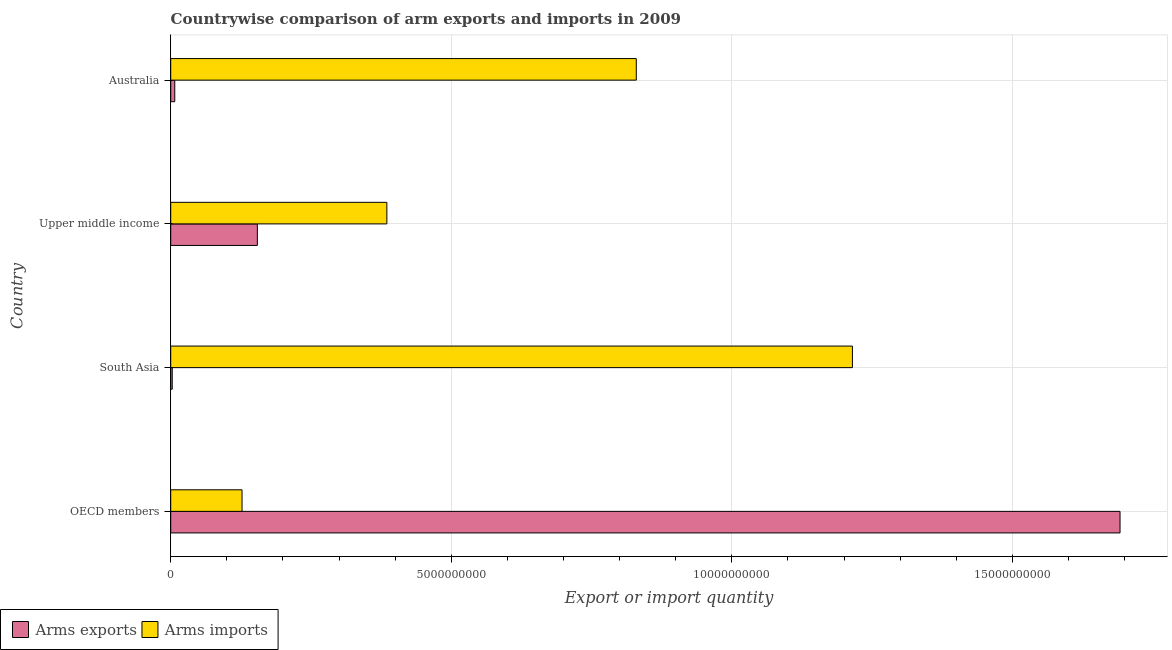How many different coloured bars are there?
Keep it short and to the point. 2. How many groups of bars are there?
Your answer should be very brief. 4. Are the number of bars per tick equal to the number of legend labels?
Offer a terse response. Yes. How many bars are there on the 1st tick from the top?
Give a very brief answer. 2. What is the arms exports in OECD members?
Ensure brevity in your answer.  1.69e+1. Across all countries, what is the maximum arms exports?
Your answer should be compact. 1.69e+1. Across all countries, what is the minimum arms imports?
Provide a succinct answer. 1.27e+09. In which country was the arms imports maximum?
Keep it short and to the point. South Asia. In which country was the arms exports minimum?
Your answer should be very brief. South Asia. What is the total arms imports in the graph?
Provide a short and direct response. 2.56e+1. What is the difference between the arms imports in Australia and that in Upper middle income?
Your answer should be very brief. 4.44e+09. What is the difference between the arms imports in Australia and the arms exports in OECD members?
Keep it short and to the point. -8.62e+09. What is the average arms imports per country?
Offer a very short reply. 6.39e+09. What is the difference between the arms imports and arms exports in Upper middle income?
Give a very brief answer. 2.31e+09. What is the ratio of the arms exports in OECD members to that in South Asia?
Your response must be concise. 626.59. Is the difference between the arms exports in Australia and Upper middle income greater than the difference between the arms imports in Australia and Upper middle income?
Provide a short and direct response. No. What is the difference between the highest and the second highest arms exports?
Your answer should be compact. 1.54e+1. What is the difference between the highest and the lowest arms exports?
Offer a terse response. 1.69e+1. What does the 1st bar from the top in OECD members represents?
Ensure brevity in your answer.  Arms imports. What does the 2nd bar from the bottom in OECD members represents?
Give a very brief answer. Arms imports. How many bars are there?
Offer a terse response. 8. What is the difference between two consecutive major ticks on the X-axis?
Offer a terse response. 5.00e+09. Are the values on the major ticks of X-axis written in scientific E-notation?
Offer a very short reply. No. Where does the legend appear in the graph?
Offer a very short reply. Bottom left. How are the legend labels stacked?
Keep it short and to the point. Horizontal. What is the title of the graph?
Provide a succinct answer. Countrywise comparison of arm exports and imports in 2009. What is the label or title of the X-axis?
Provide a short and direct response. Export or import quantity. What is the label or title of the Y-axis?
Offer a terse response. Country. What is the Export or import quantity of Arms exports in OECD members?
Ensure brevity in your answer.  1.69e+1. What is the Export or import quantity in Arms imports in OECD members?
Offer a terse response. 1.27e+09. What is the Export or import quantity of Arms exports in South Asia?
Your response must be concise. 2.70e+07. What is the Export or import quantity of Arms imports in South Asia?
Offer a very short reply. 1.21e+1. What is the Export or import quantity of Arms exports in Upper middle income?
Offer a very short reply. 1.54e+09. What is the Export or import quantity of Arms imports in Upper middle income?
Your answer should be compact. 3.85e+09. What is the Export or import quantity of Arms exports in Australia?
Make the answer very short. 7.20e+07. What is the Export or import quantity of Arms imports in Australia?
Give a very brief answer. 8.30e+09. Across all countries, what is the maximum Export or import quantity of Arms exports?
Offer a terse response. 1.69e+1. Across all countries, what is the maximum Export or import quantity in Arms imports?
Your answer should be very brief. 1.21e+1. Across all countries, what is the minimum Export or import quantity of Arms exports?
Make the answer very short. 2.70e+07. Across all countries, what is the minimum Export or import quantity in Arms imports?
Your response must be concise. 1.27e+09. What is the total Export or import quantity of Arms exports in the graph?
Ensure brevity in your answer.  1.86e+1. What is the total Export or import quantity in Arms imports in the graph?
Provide a short and direct response. 2.56e+1. What is the difference between the Export or import quantity in Arms exports in OECD members and that in South Asia?
Ensure brevity in your answer.  1.69e+1. What is the difference between the Export or import quantity in Arms imports in OECD members and that in South Asia?
Your answer should be compact. -1.09e+1. What is the difference between the Export or import quantity in Arms exports in OECD members and that in Upper middle income?
Provide a short and direct response. 1.54e+1. What is the difference between the Export or import quantity in Arms imports in OECD members and that in Upper middle income?
Offer a terse response. -2.58e+09. What is the difference between the Export or import quantity of Arms exports in OECD members and that in Australia?
Give a very brief answer. 1.68e+1. What is the difference between the Export or import quantity of Arms imports in OECD members and that in Australia?
Provide a short and direct response. -7.03e+09. What is the difference between the Export or import quantity of Arms exports in South Asia and that in Upper middle income?
Ensure brevity in your answer.  -1.52e+09. What is the difference between the Export or import quantity in Arms imports in South Asia and that in Upper middle income?
Give a very brief answer. 8.30e+09. What is the difference between the Export or import quantity in Arms exports in South Asia and that in Australia?
Keep it short and to the point. -4.50e+07. What is the difference between the Export or import quantity in Arms imports in South Asia and that in Australia?
Make the answer very short. 3.85e+09. What is the difference between the Export or import quantity in Arms exports in Upper middle income and that in Australia?
Make the answer very short. 1.47e+09. What is the difference between the Export or import quantity in Arms imports in Upper middle income and that in Australia?
Your answer should be very brief. -4.44e+09. What is the difference between the Export or import quantity in Arms exports in OECD members and the Export or import quantity in Arms imports in South Asia?
Your response must be concise. 4.77e+09. What is the difference between the Export or import quantity in Arms exports in OECD members and the Export or import quantity in Arms imports in Upper middle income?
Your answer should be compact. 1.31e+1. What is the difference between the Export or import quantity of Arms exports in OECD members and the Export or import quantity of Arms imports in Australia?
Make the answer very short. 8.62e+09. What is the difference between the Export or import quantity of Arms exports in South Asia and the Export or import quantity of Arms imports in Upper middle income?
Your response must be concise. -3.82e+09. What is the difference between the Export or import quantity of Arms exports in South Asia and the Export or import quantity of Arms imports in Australia?
Provide a short and direct response. -8.27e+09. What is the difference between the Export or import quantity in Arms exports in Upper middle income and the Export or import quantity in Arms imports in Australia?
Ensure brevity in your answer.  -6.75e+09. What is the average Export or import quantity in Arms exports per country?
Your answer should be compact. 4.64e+09. What is the average Export or import quantity in Arms imports per country?
Make the answer very short. 6.39e+09. What is the difference between the Export or import quantity of Arms exports and Export or import quantity of Arms imports in OECD members?
Ensure brevity in your answer.  1.56e+1. What is the difference between the Export or import quantity in Arms exports and Export or import quantity in Arms imports in South Asia?
Provide a succinct answer. -1.21e+1. What is the difference between the Export or import quantity of Arms exports and Export or import quantity of Arms imports in Upper middle income?
Give a very brief answer. -2.31e+09. What is the difference between the Export or import quantity in Arms exports and Export or import quantity in Arms imports in Australia?
Offer a terse response. -8.22e+09. What is the ratio of the Export or import quantity of Arms exports in OECD members to that in South Asia?
Offer a terse response. 626.59. What is the ratio of the Export or import quantity of Arms imports in OECD members to that in South Asia?
Your answer should be compact. 0.1. What is the ratio of the Export or import quantity of Arms exports in OECD members to that in Upper middle income?
Your response must be concise. 10.96. What is the ratio of the Export or import quantity of Arms imports in OECD members to that in Upper middle income?
Give a very brief answer. 0.33. What is the ratio of the Export or import quantity of Arms exports in OECD members to that in Australia?
Offer a very short reply. 234.97. What is the ratio of the Export or import quantity of Arms imports in OECD members to that in Australia?
Give a very brief answer. 0.15. What is the ratio of the Export or import quantity in Arms exports in South Asia to that in Upper middle income?
Provide a succinct answer. 0.02. What is the ratio of the Export or import quantity of Arms imports in South Asia to that in Upper middle income?
Ensure brevity in your answer.  3.15. What is the ratio of the Export or import quantity in Arms exports in South Asia to that in Australia?
Give a very brief answer. 0.38. What is the ratio of the Export or import quantity of Arms imports in South Asia to that in Australia?
Provide a short and direct response. 1.46. What is the ratio of the Export or import quantity of Arms exports in Upper middle income to that in Australia?
Offer a terse response. 21.44. What is the ratio of the Export or import quantity in Arms imports in Upper middle income to that in Australia?
Provide a succinct answer. 0.46. What is the difference between the highest and the second highest Export or import quantity of Arms exports?
Make the answer very short. 1.54e+1. What is the difference between the highest and the second highest Export or import quantity of Arms imports?
Provide a succinct answer. 3.85e+09. What is the difference between the highest and the lowest Export or import quantity of Arms exports?
Provide a short and direct response. 1.69e+1. What is the difference between the highest and the lowest Export or import quantity in Arms imports?
Provide a succinct answer. 1.09e+1. 